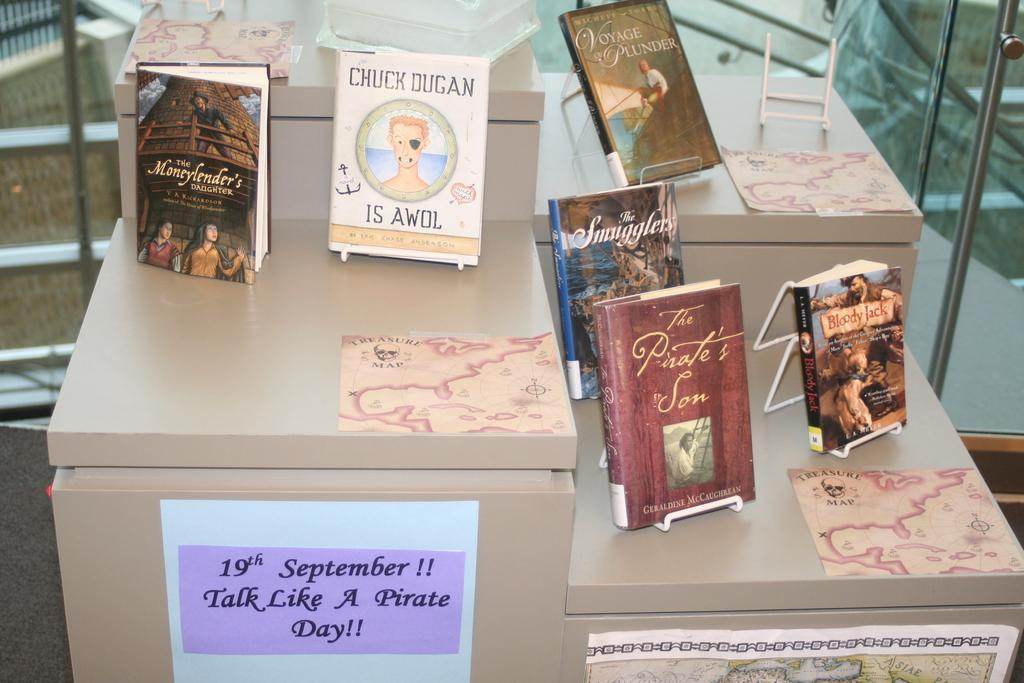What is the main object in the image? There is an object that looks like a table in the image. What is placed on the table? There are books with text on the table. Are there any additional items attached to the books? Yes, some papers are attached to the books. What can be seen in the background of the image? There are stairs visible in the background of the image. How many uncles are present in the image? There are no uncles present in the image. What act are the men performing in the image? There are no men or acts depicted in the image. 